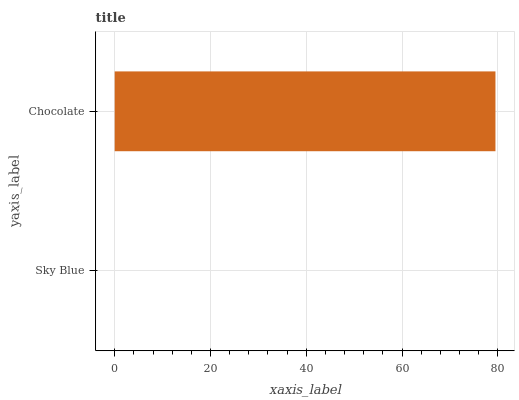Is Sky Blue the minimum?
Answer yes or no. Yes. Is Chocolate the maximum?
Answer yes or no. Yes. Is Chocolate the minimum?
Answer yes or no. No. Is Chocolate greater than Sky Blue?
Answer yes or no. Yes. Is Sky Blue less than Chocolate?
Answer yes or no. Yes. Is Sky Blue greater than Chocolate?
Answer yes or no. No. Is Chocolate less than Sky Blue?
Answer yes or no. No. Is Chocolate the high median?
Answer yes or no. Yes. Is Sky Blue the low median?
Answer yes or no. Yes. Is Sky Blue the high median?
Answer yes or no. No. Is Chocolate the low median?
Answer yes or no. No. 